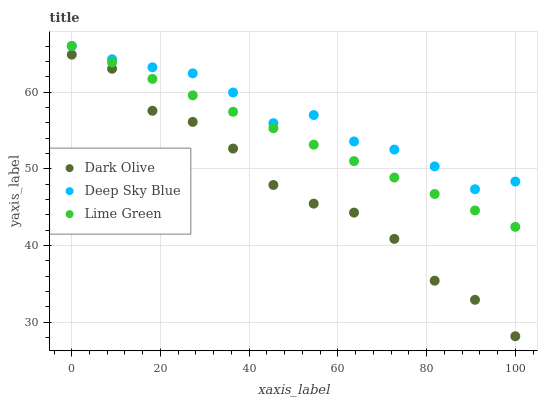Does Dark Olive have the minimum area under the curve?
Answer yes or no. Yes. Does Deep Sky Blue have the maximum area under the curve?
Answer yes or no. Yes. Does Lime Green have the minimum area under the curve?
Answer yes or no. No. Does Lime Green have the maximum area under the curve?
Answer yes or no. No. Is Lime Green the smoothest?
Answer yes or no. Yes. Is Dark Olive the roughest?
Answer yes or no. Yes. Is Deep Sky Blue the smoothest?
Answer yes or no. No. Is Deep Sky Blue the roughest?
Answer yes or no. No. Does Dark Olive have the lowest value?
Answer yes or no. Yes. Does Lime Green have the lowest value?
Answer yes or no. No. Does Deep Sky Blue have the highest value?
Answer yes or no. Yes. Is Dark Olive less than Lime Green?
Answer yes or no. Yes. Is Lime Green greater than Dark Olive?
Answer yes or no. Yes. Does Deep Sky Blue intersect Lime Green?
Answer yes or no. Yes. Is Deep Sky Blue less than Lime Green?
Answer yes or no. No. Is Deep Sky Blue greater than Lime Green?
Answer yes or no. No. Does Dark Olive intersect Lime Green?
Answer yes or no. No. 